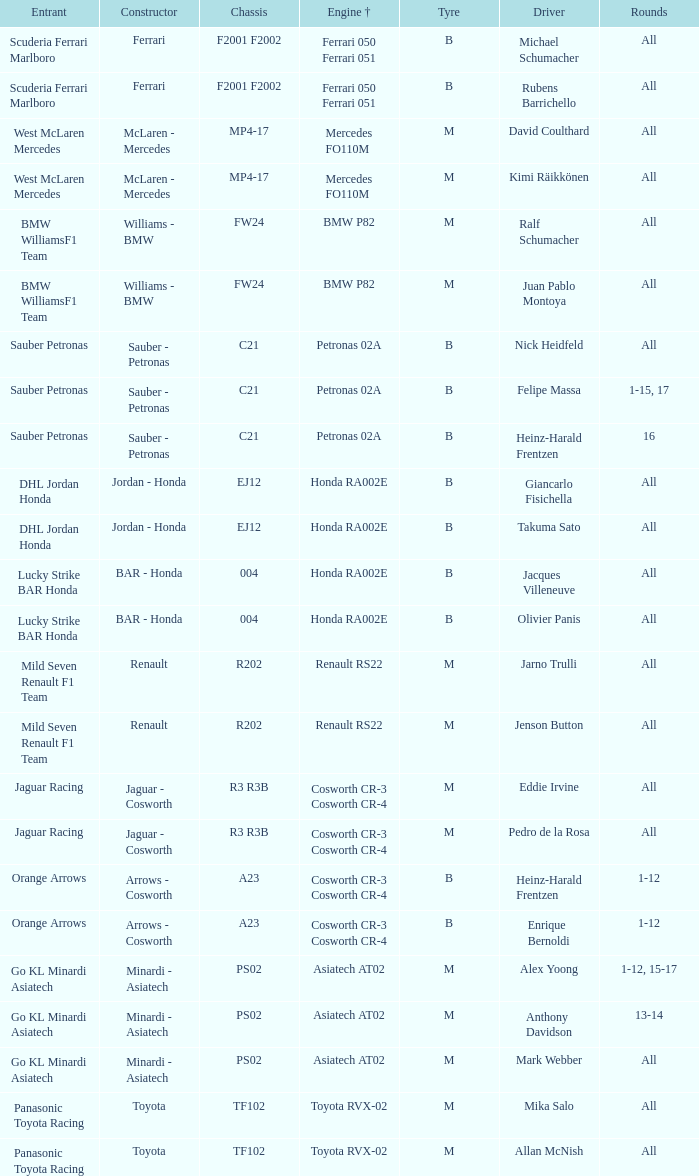Who is the chauffeur when the powertrain is mercedes fo110m? David Coulthard, Kimi Räikkönen. 